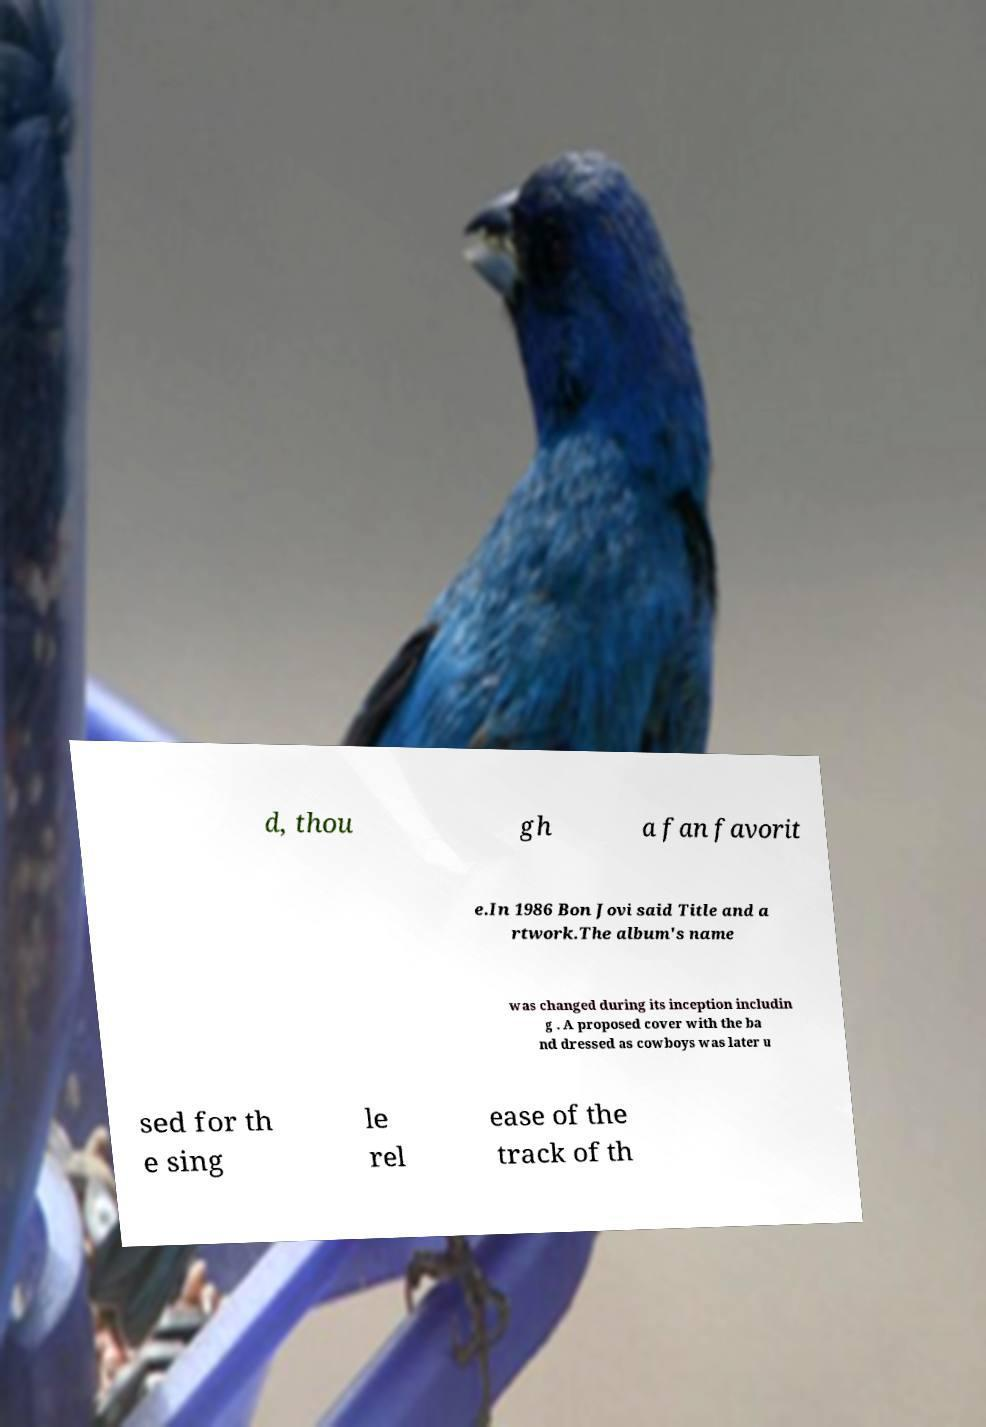Can you accurately transcribe the text from the provided image for me? d, thou gh a fan favorit e.In 1986 Bon Jovi said Title and a rtwork.The album's name was changed during its inception includin g . A proposed cover with the ba nd dressed as cowboys was later u sed for th e sing le rel ease of the track of th 